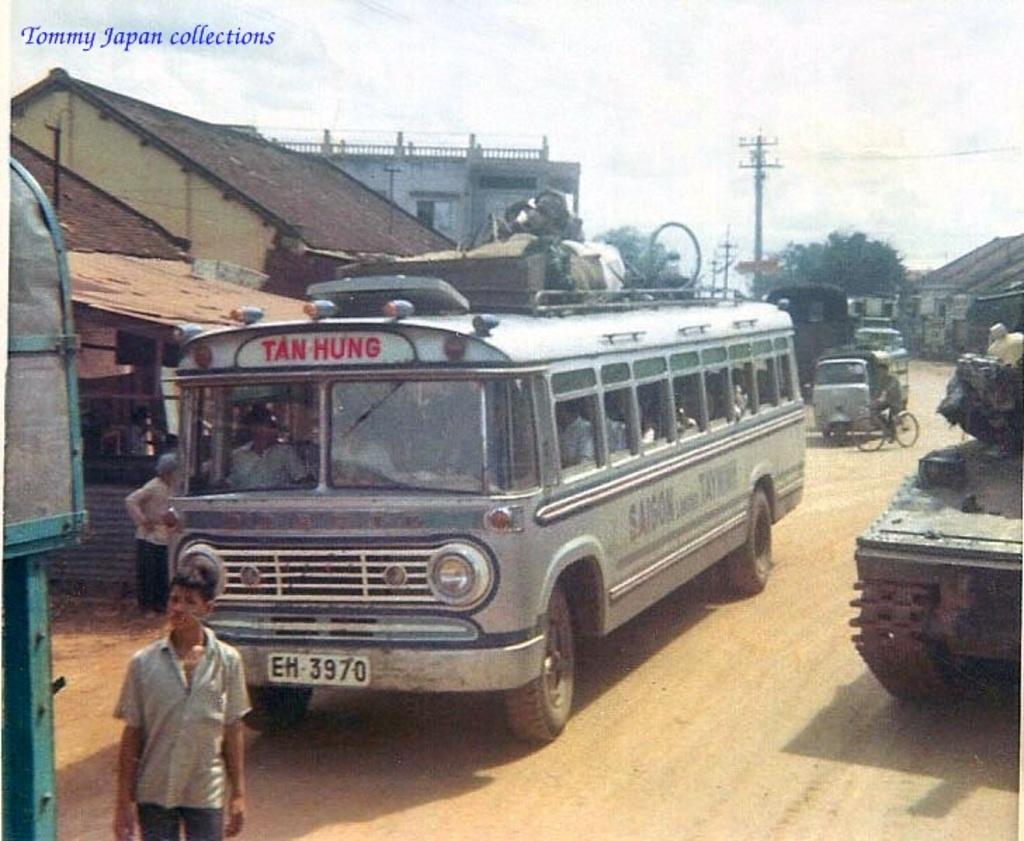<image>
Present a compact description of the photo's key features. A photo from Tommy Japan Collections shows a bus that says Tan Hung with the license EH 3970 next to a tank. 